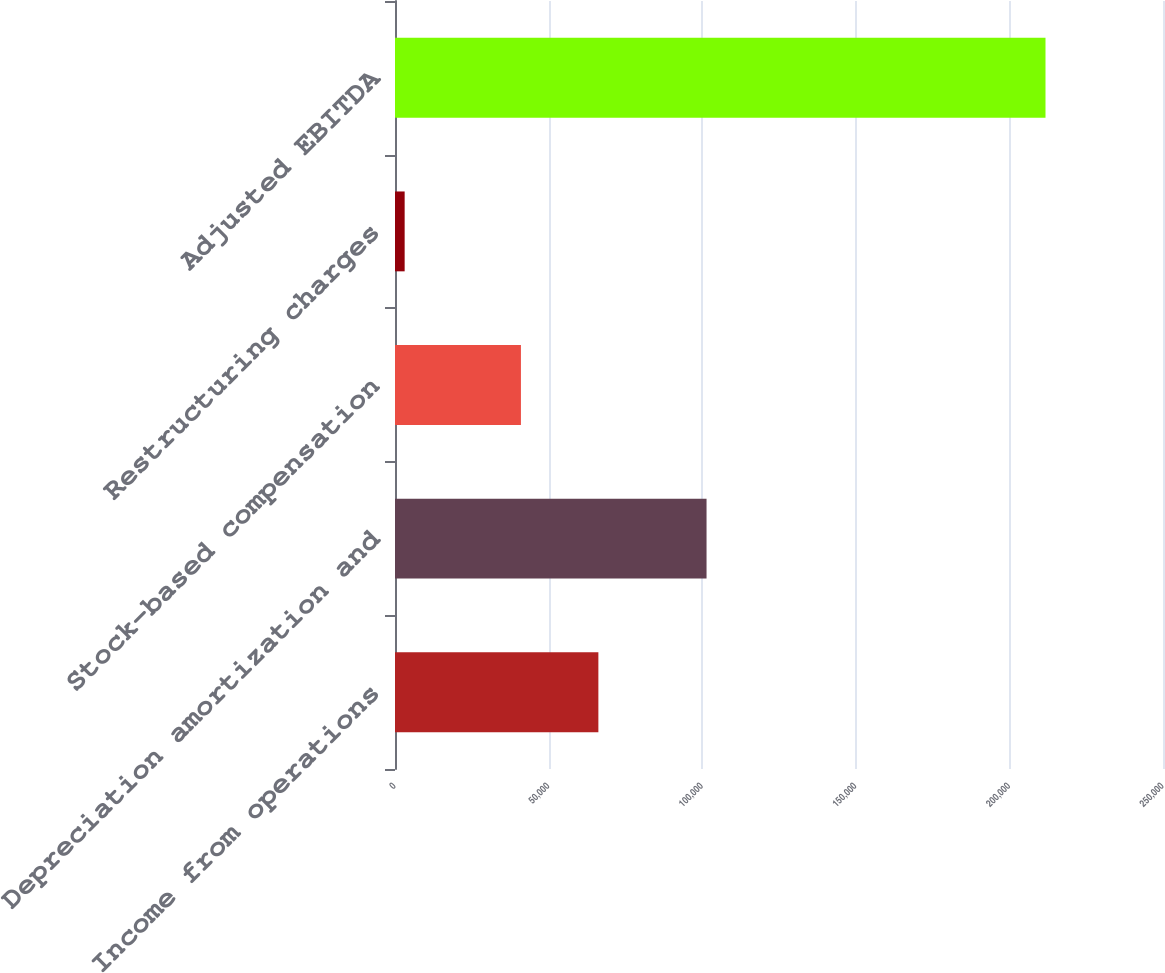Convert chart to OTSL. <chart><loc_0><loc_0><loc_500><loc_500><bar_chart><fcel>Income from operations<fcel>Depreciation amortization and<fcel>Stock-based compensation<fcel>Restructuring charges<fcel>Adjusted EBITDA<nl><fcel>66202<fcel>101414<fcel>40993<fcel>3142<fcel>211751<nl></chart> 